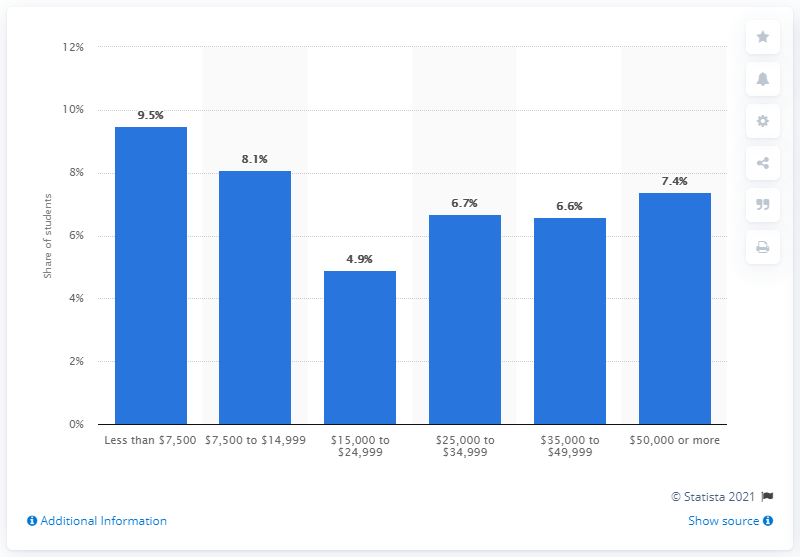Draw attention to some important aspects in this diagram. According to a survey conducted during the school year 2012-13, 6.7% of students between the ages of 12 and 18 were harassed and bullied online. 